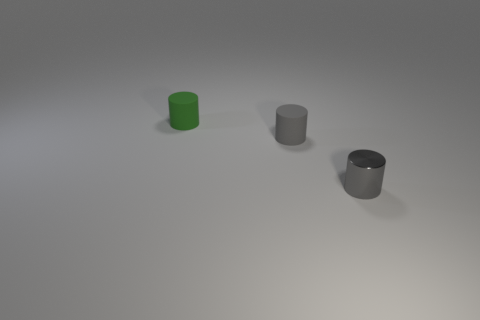Add 2 green rubber cylinders. How many objects exist? 5 Add 3 tiny rubber objects. How many tiny rubber objects are left? 5 Add 2 tiny gray cylinders. How many tiny gray cylinders exist? 4 Subtract 0 blue cylinders. How many objects are left? 3 Subtract all small green rubber objects. Subtract all big cyan rubber blocks. How many objects are left? 2 